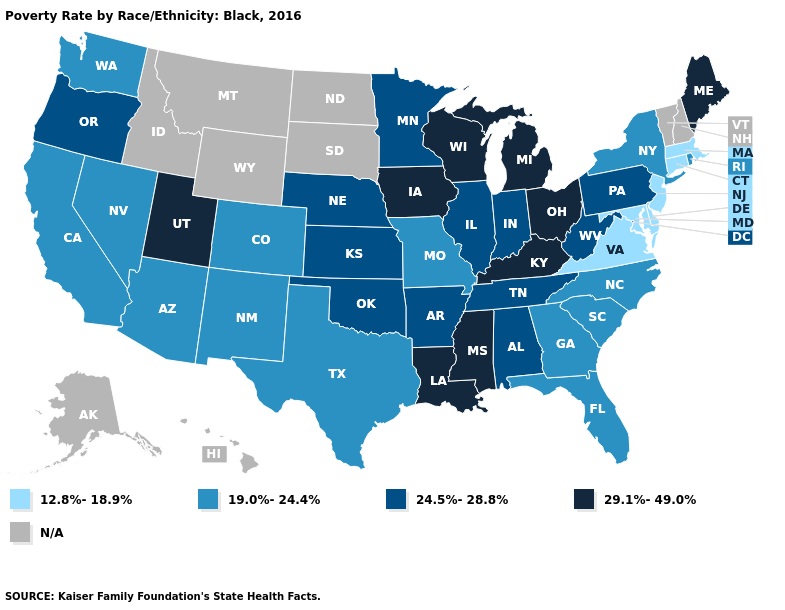Is the legend a continuous bar?
Write a very short answer. No. Name the states that have a value in the range N/A?
Concise answer only. Alaska, Hawaii, Idaho, Montana, New Hampshire, North Dakota, South Dakota, Vermont, Wyoming. Does Pennsylvania have the highest value in the Northeast?
Concise answer only. No. Does Tennessee have the highest value in the USA?
Answer briefly. No. What is the highest value in states that border Nebraska?
Keep it brief. 29.1%-49.0%. Name the states that have a value in the range 12.8%-18.9%?
Quick response, please. Connecticut, Delaware, Maryland, Massachusetts, New Jersey, Virginia. Is the legend a continuous bar?
Give a very brief answer. No. What is the value of Vermont?
Write a very short answer. N/A. Which states have the highest value in the USA?
Concise answer only. Iowa, Kentucky, Louisiana, Maine, Michigan, Mississippi, Ohio, Utah, Wisconsin. Does Connecticut have the highest value in the Northeast?
Give a very brief answer. No. Does the map have missing data?
Be succinct. Yes. Name the states that have a value in the range 29.1%-49.0%?
Concise answer only. Iowa, Kentucky, Louisiana, Maine, Michigan, Mississippi, Ohio, Utah, Wisconsin. What is the value of Washington?
Be succinct. 19.0%-24.4%. What is the value of Nebraska?
Concise answer only. 24.5%-28.8%. Does Mississippi have the highest value in the USA?
Quick response, please. Yes. 